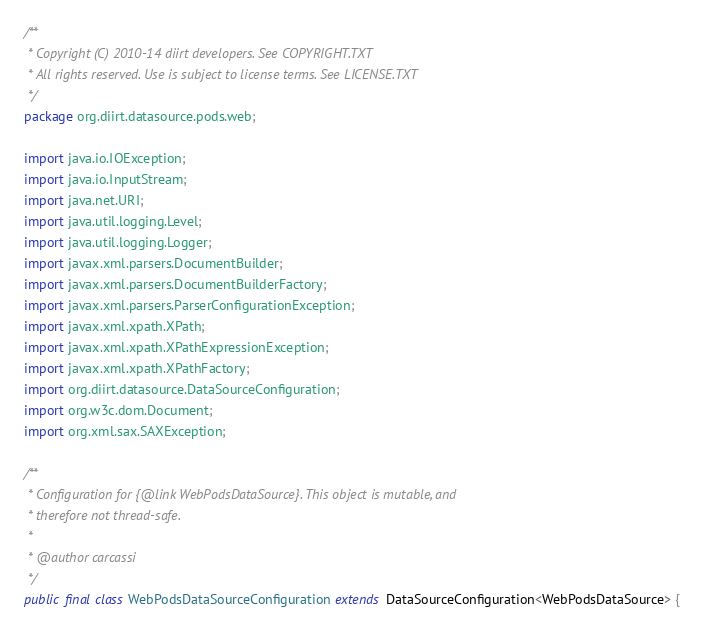<code> <loc_0><loc_0><loc_500><loc_500><_Java_>/**
 * Copyright (C) 2010-14 diirt developers. See COPYRIGHT.TXT
 * All rights reserved. Use is subject to license terms. See LICENSE.TXT
 */
package org.diirt.datasource.pods.web;

import java.io.IOException;
import java.io.InputStream;
import java.net.URI;
import java.util.logging.Level;
import java.util.logging.Logger;
import javax.xml.parsers.DocumentBuilder;
import javax.xml.parsers.DocumentBuilderFactory;
import javax.xml.parsers.ParserConfigurationException;
import javax.xml.xpath.XPath;
import javax.xml.xpath.XPathExpressionException;
import javax.xml.xpath.XPathFactory;
import org.diirt.datasource.DataSourceConfiguration;
import org.w3c.dom.Document;
import org.xml.sax.SAXException;

/**
 * Configuration for {@link WebPodsDataSource}. This object is mutable, and
 * therefore not thread-safe.
 *
 * @author carcassi
 */
public final class WebPodsDataSourceConfiguration extends DataSourceConfiguration<WebPodsDataSource> {
</code> 